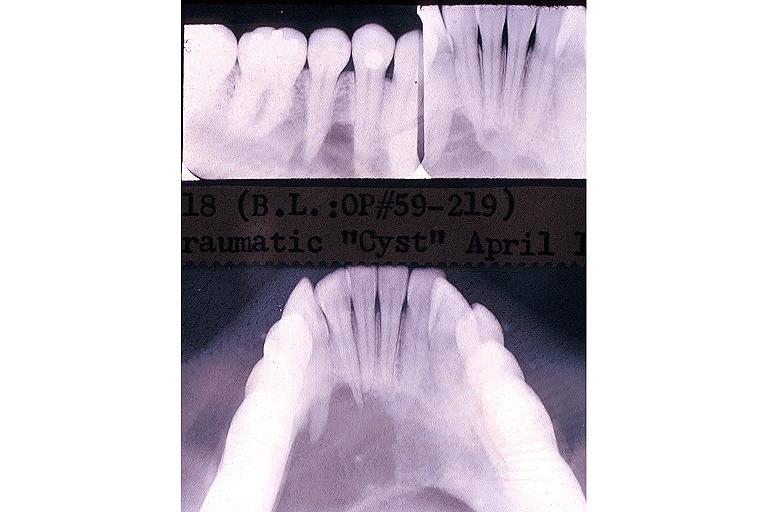does autoimmune thyroiditis show traumatic bone cyst simple bone cyst?
Answer the question using a single word or phrase. No 